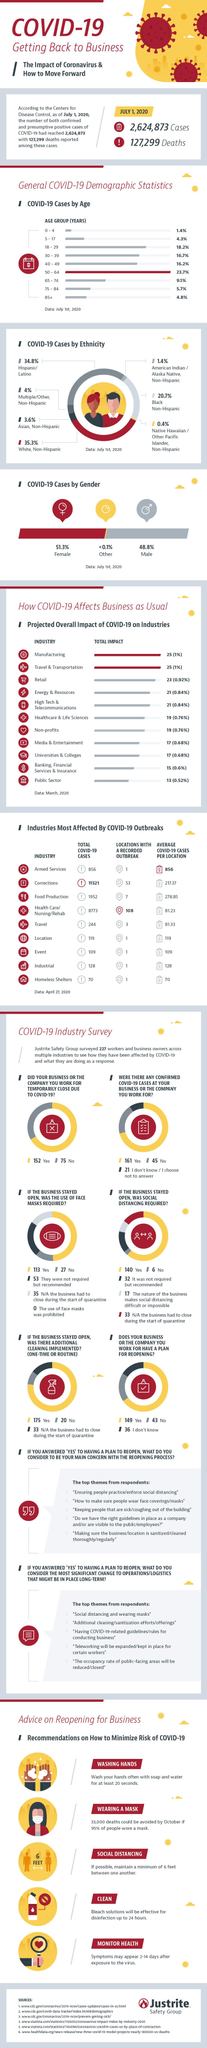Outline some significant characteristics in this image. As of April 27, 2020, the total number of COVID-19 cases reported in the armed services of the United States was 856. The age group of 50-64 in America has recorded the highest percentage of COVID-19 cases as of July 1, 2020. The industry survey found that 152 respondents agreed that their business or company would temporarily close due to COVID-19. As of July 1, 2020, approximately 16.2% of COVID-19 cases in the United States were among individuals aged 40-49 years old. As of July 1, 2020, it was reported that 48.8% of males in the United States were affected by the Covid-19 virus. 